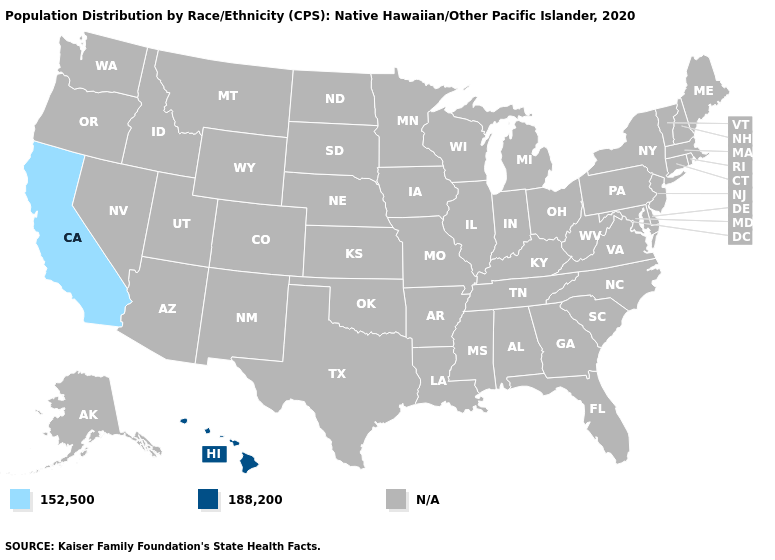Does the map have missing data?
Give a very brief answer. Yes. What is the lowest value in the West?
Keep it brief. 152,500. What is the value of Alaska?
Be succinct. N/A. Name the states that have a value in the range 152,500?
Concise answer only. California. Does California have the lowest value in the USA?
Write a very short answer. Yes. How many symbols are there in the legend?
Answer briefly. 3. Does Hawaii have the highest value in the USA?
Quick response, please. Yes. What is the value of Minnesota?
Keep it brief. N/A. Is the legend a continuous bar?
Quick response, please. No. Which states have the lowest value in the USA?
Concise answer only. California. Does the map have missing data?
Answer briefly. Yes. What is the value of South Carolina?
Give a very brief answer. N/A. 